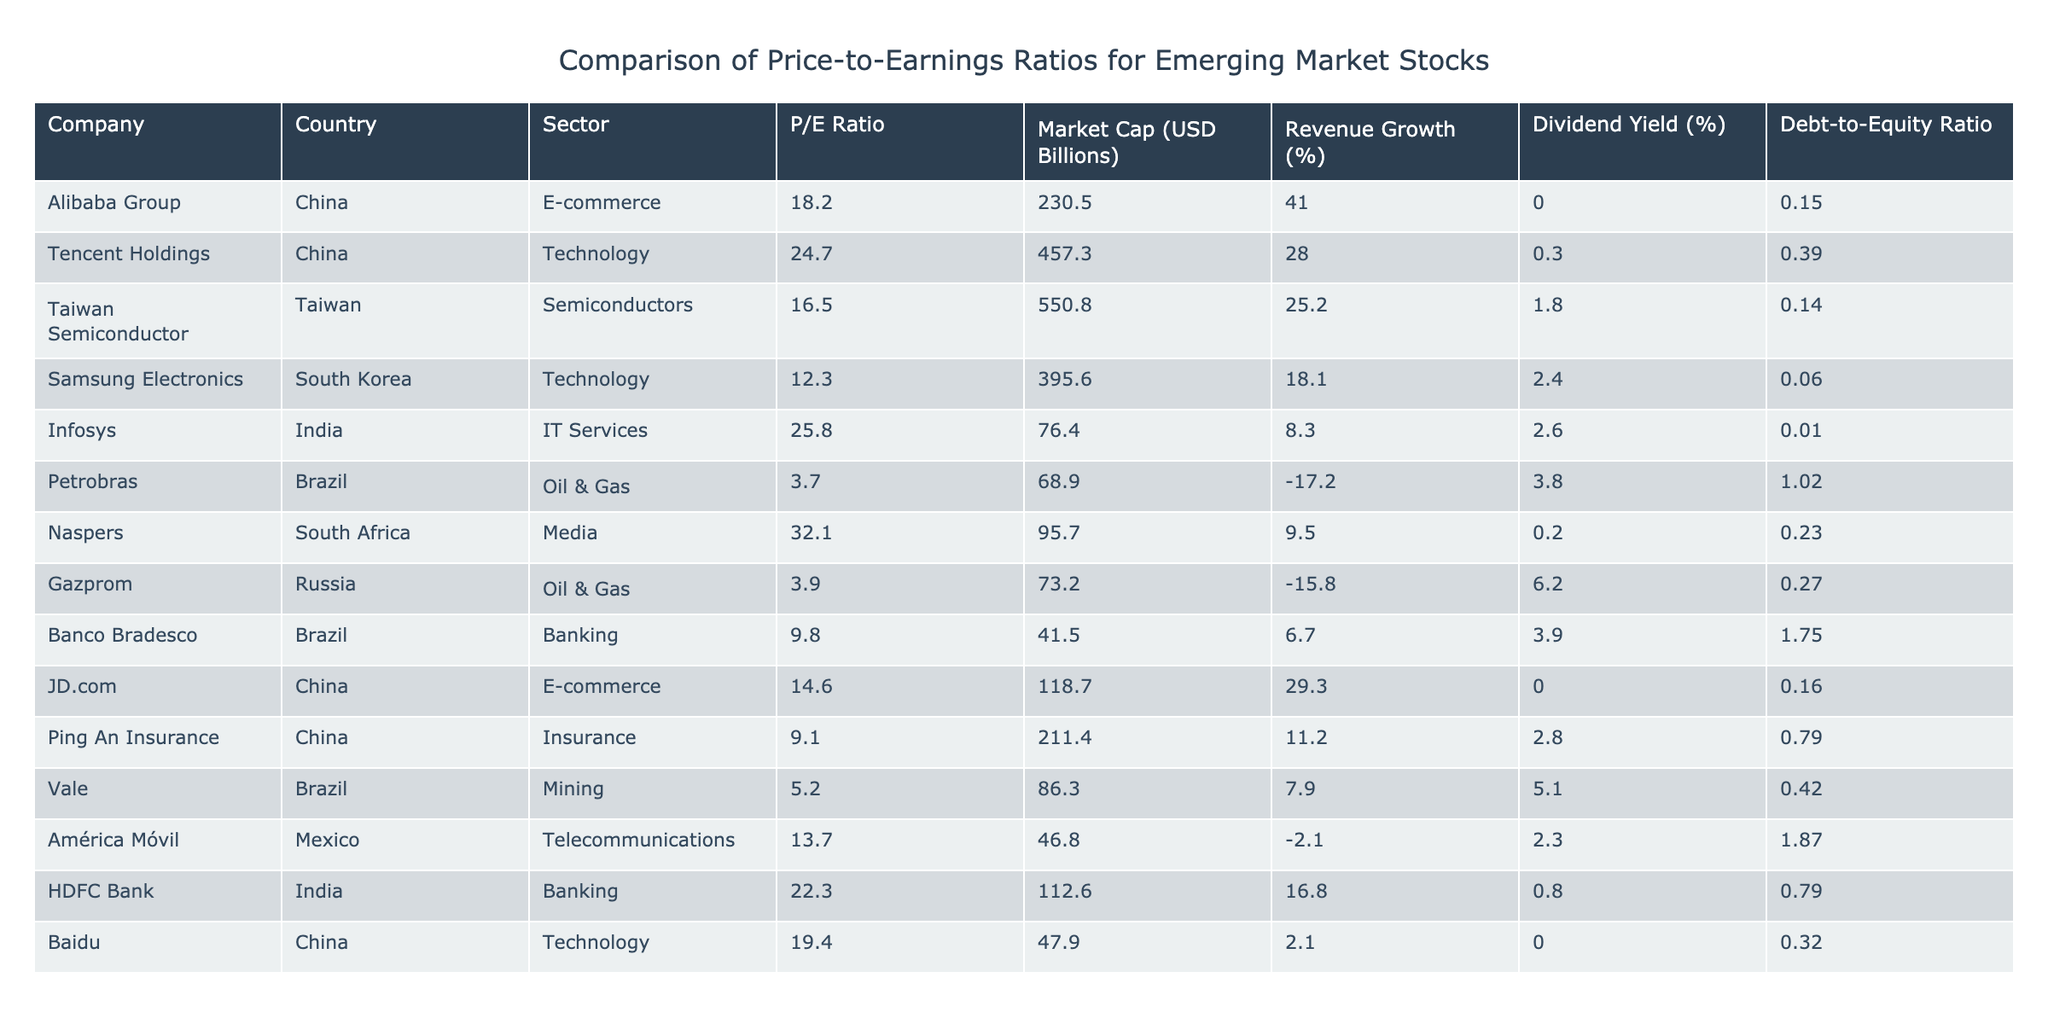What is the P/E ratio of Tencent Holdings? Looking at the table, Tencent Holdings is listed under the Company column. In the same row, the P/E Ratio column shows a value of 24.7.
Answer: 24.7 Which company has the highest market capitalization? The Market Cap column lists the values for each company. By comparing these values, we find that Taiwan Semiconductor has the highest market cap of 550.8 billion USD.
Answer: Taiwan Semiconductor Is the P/E ratio of Petrobras greater than the P/E ratio of Vale? Petrobras has a P/E ratio of 3.7, while Vale has a P/E ratio of 5.2. Since 3.7 is less than 5.2, the statement is false.
Answer: No What is the average P/E ratio of the companies listed in the table? The P/E ratios are: 18.2, 24.7, 16.5, 12.3, 25.8, 3.7, 32.1, 3.9, 9.8, 14.6, 22.3, 19.4. Adding these values gives  18.2 + 24.7 + 16.5 + 12.3 + 25.8 + 3.7 + 32.1 + 3.9 + 9.8 + 14.6 + 22.3 + 19.4 =  233.0. There are 12 companies, so the average is 233.0 / 12 = 19.42.
Answer: 19.42 Which country has the company with the lowest P/E ratio? Looking at the P/E ratios, Petrobras (Brazil) has the lowest at 3.7, compared to Gazprom (Russia) at 3.9. Therefore, Brazil has the company with the lowest P/E.
Answer: Brazil How many companies have a P/E ratio above 20? Reviewing the P/E ratios in the table, those above 20 are: Tencent Holdings (24.7), Infosys (25.8), Naspers (32.1), HDFC Bank (22.3), and Baidu (19.4). That makes a total of 4 companies.
Answer: 4 Which company has the highest P/E ratio among those in the technology sector? The technology companies listed are Tencent Holdings (24.7), Samsung Electronics (12.3), Infosys (25.8), and Baidu (19.4). By comparing their P/E ratios, we find that Tencent Holdings has the highest P/E of 24.7.
Answer: Tencent Holdings Is there a company in the table with a dividend yield greater than 5%? Looking at the Dividend Yield column, Vale has a yield of 5.1%, which is greater than 5%. Therefore, there is a company with a dividend yield greater than 5%.
Answer: Yes What is the difference in P/E ratios between Naspers and Ping An Insurance? The P/E ratio of Naspers is 32.1 and for Ping An Insurance, it is 9.1. To find the difference, we subtract: 32.1 - 9.1 = 23.0.
Answer: 23.0 Which sector has the company with the highest debt-to-equity ratio? The table shows debt-to-equity ratios, with Petrobras (Oil & Gas) having a ratio of 1.02, which is the highest compared to others. Hence, the sector with the highest debt-to-equity ratio is Oil & Gas.
Answer: Oil & Gas Are there any companies from Brazil in the table that have a P/E ratio above 10? Banco Bradesco has a P/E ratio of 9.8, while Petrobras has a P/E ratio of 3.7. Therefore, neither of the Brazilian companies has a P/E ratio above 10.
Answer: No 